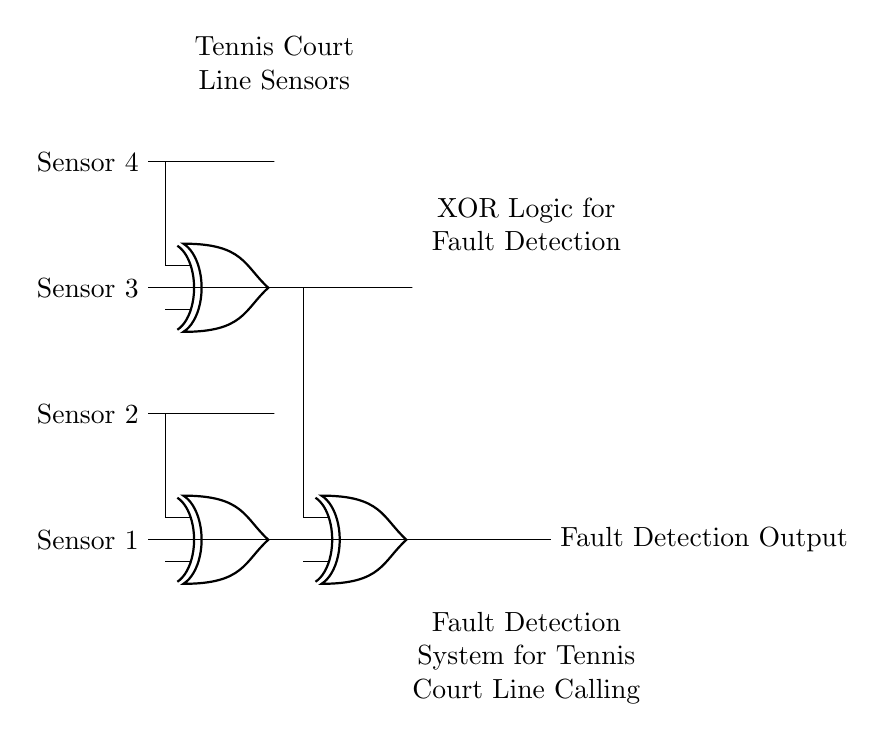What are the input sensors used in the circuit? The circuit diagram shows four input sensors: Sensor 1, Sensor 2, Sensor 3, and Sensor 4, which are connected to the XOR gates for detecting faults in the system.
Answer: Sensor 1, Sensor 2, Sensor 3, Sensor 4 How many XOR gates are present in the circuit? By analyzing the circuit diagram, there are three distinct XOR gates indicated; the first two XOR gates take input from the sensors and the third combines their outputs.
Answer: Three What is the output of the circuit labeled as? The output from the last XOR gate is labeled "Fault Detection Output," indicating the function of the circuit to identify any faults.
Answer: Fault Detection Output Which XOR gate connects to the output? The third XOR gate (xor3) at the far right of the circuit is responsible for providing the final output after receiving inputs from the previous XOR gates.
Answer: Third What logical operation do the XOR gates perform in this circuit? XOR gates perform the exclusive OR operation, producing a high output only when an odd number of inputs are high, which is suitable for detecting discrepancies from the sensors.
Answer: Exclusive OR If all sensors are functioning correctly, what will be the output? When all sensors provide consistent signals (aligned with the correct line calls), the XOR gates will output low, indicating no faults.
Answer: Low 